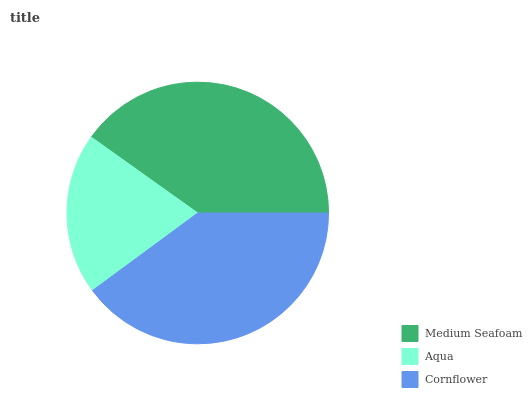Is Aqua the minimum?
Answer yes or no. Yes. Is Medium Seafoam the maximum?
Answer yes or no. Yes. Is Cornflower the minimum?
Answer yes or no. No. Is Cornflower the maximum?
Answer yes or no. No. Is Cornflower greater than Aqua?
Answer yes or no. Yes. Is Aqua less than Cornflower?
Answer yes or no. Yes. Is Aqua greater than Cornflower?
Answer yes or no. No. Is Cornflower less than Aqua?
Answer yes or no. No. Is Cornflower the high median?
Answer yes or no. Yes. Is Cornflower the low median?
Answer yes or no. Yes. Is Aqua the high median?
Answer yes or no. No. Is Medium Seafoam the low median?
Answer yes or no. No. 